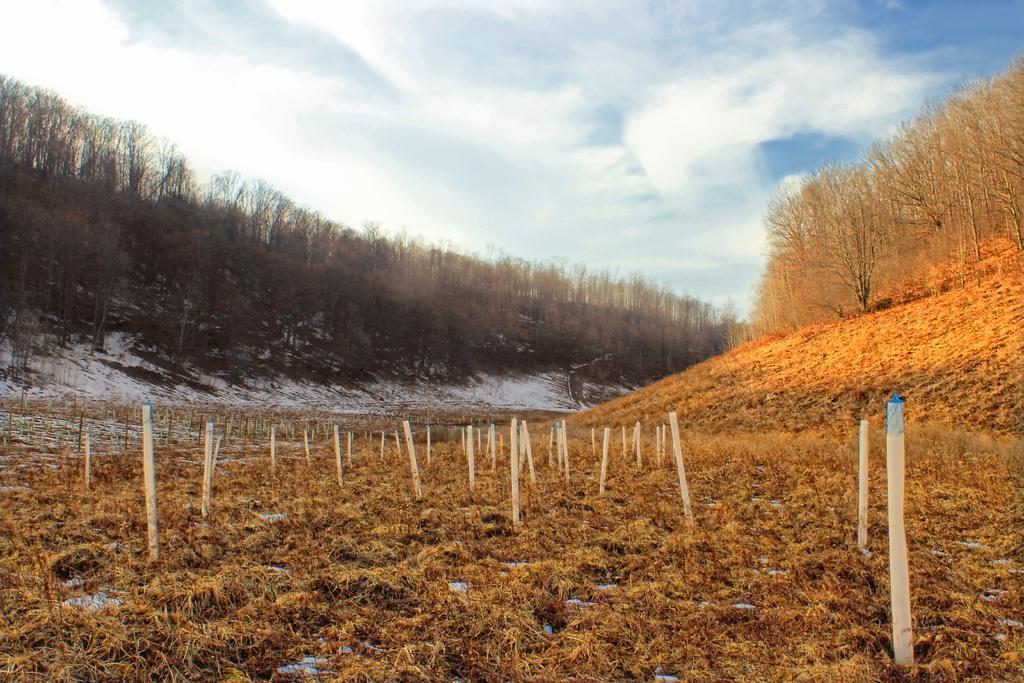Please provide a concise description of this image. In this picture I can see there is dry grass, few wooden poles, there is snow on the floor on the left side. There are few trees at left and right sides. The sky is clear. 